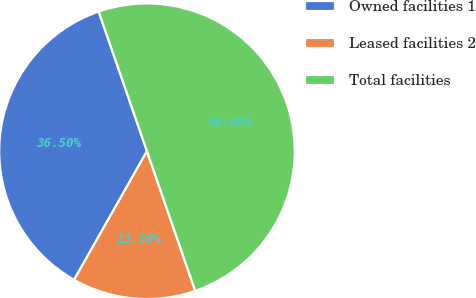Convert chart to OTSL. <chart><loc_0><loc_0><loc_500><loc_500><pie_chart><fcel>Owned facilities 1<fcel>Leased facilities 2<fcel>Total facilities<nl><fcel>36.5%<fcel>13.5%<fcel>50.0%<nl></chart> 